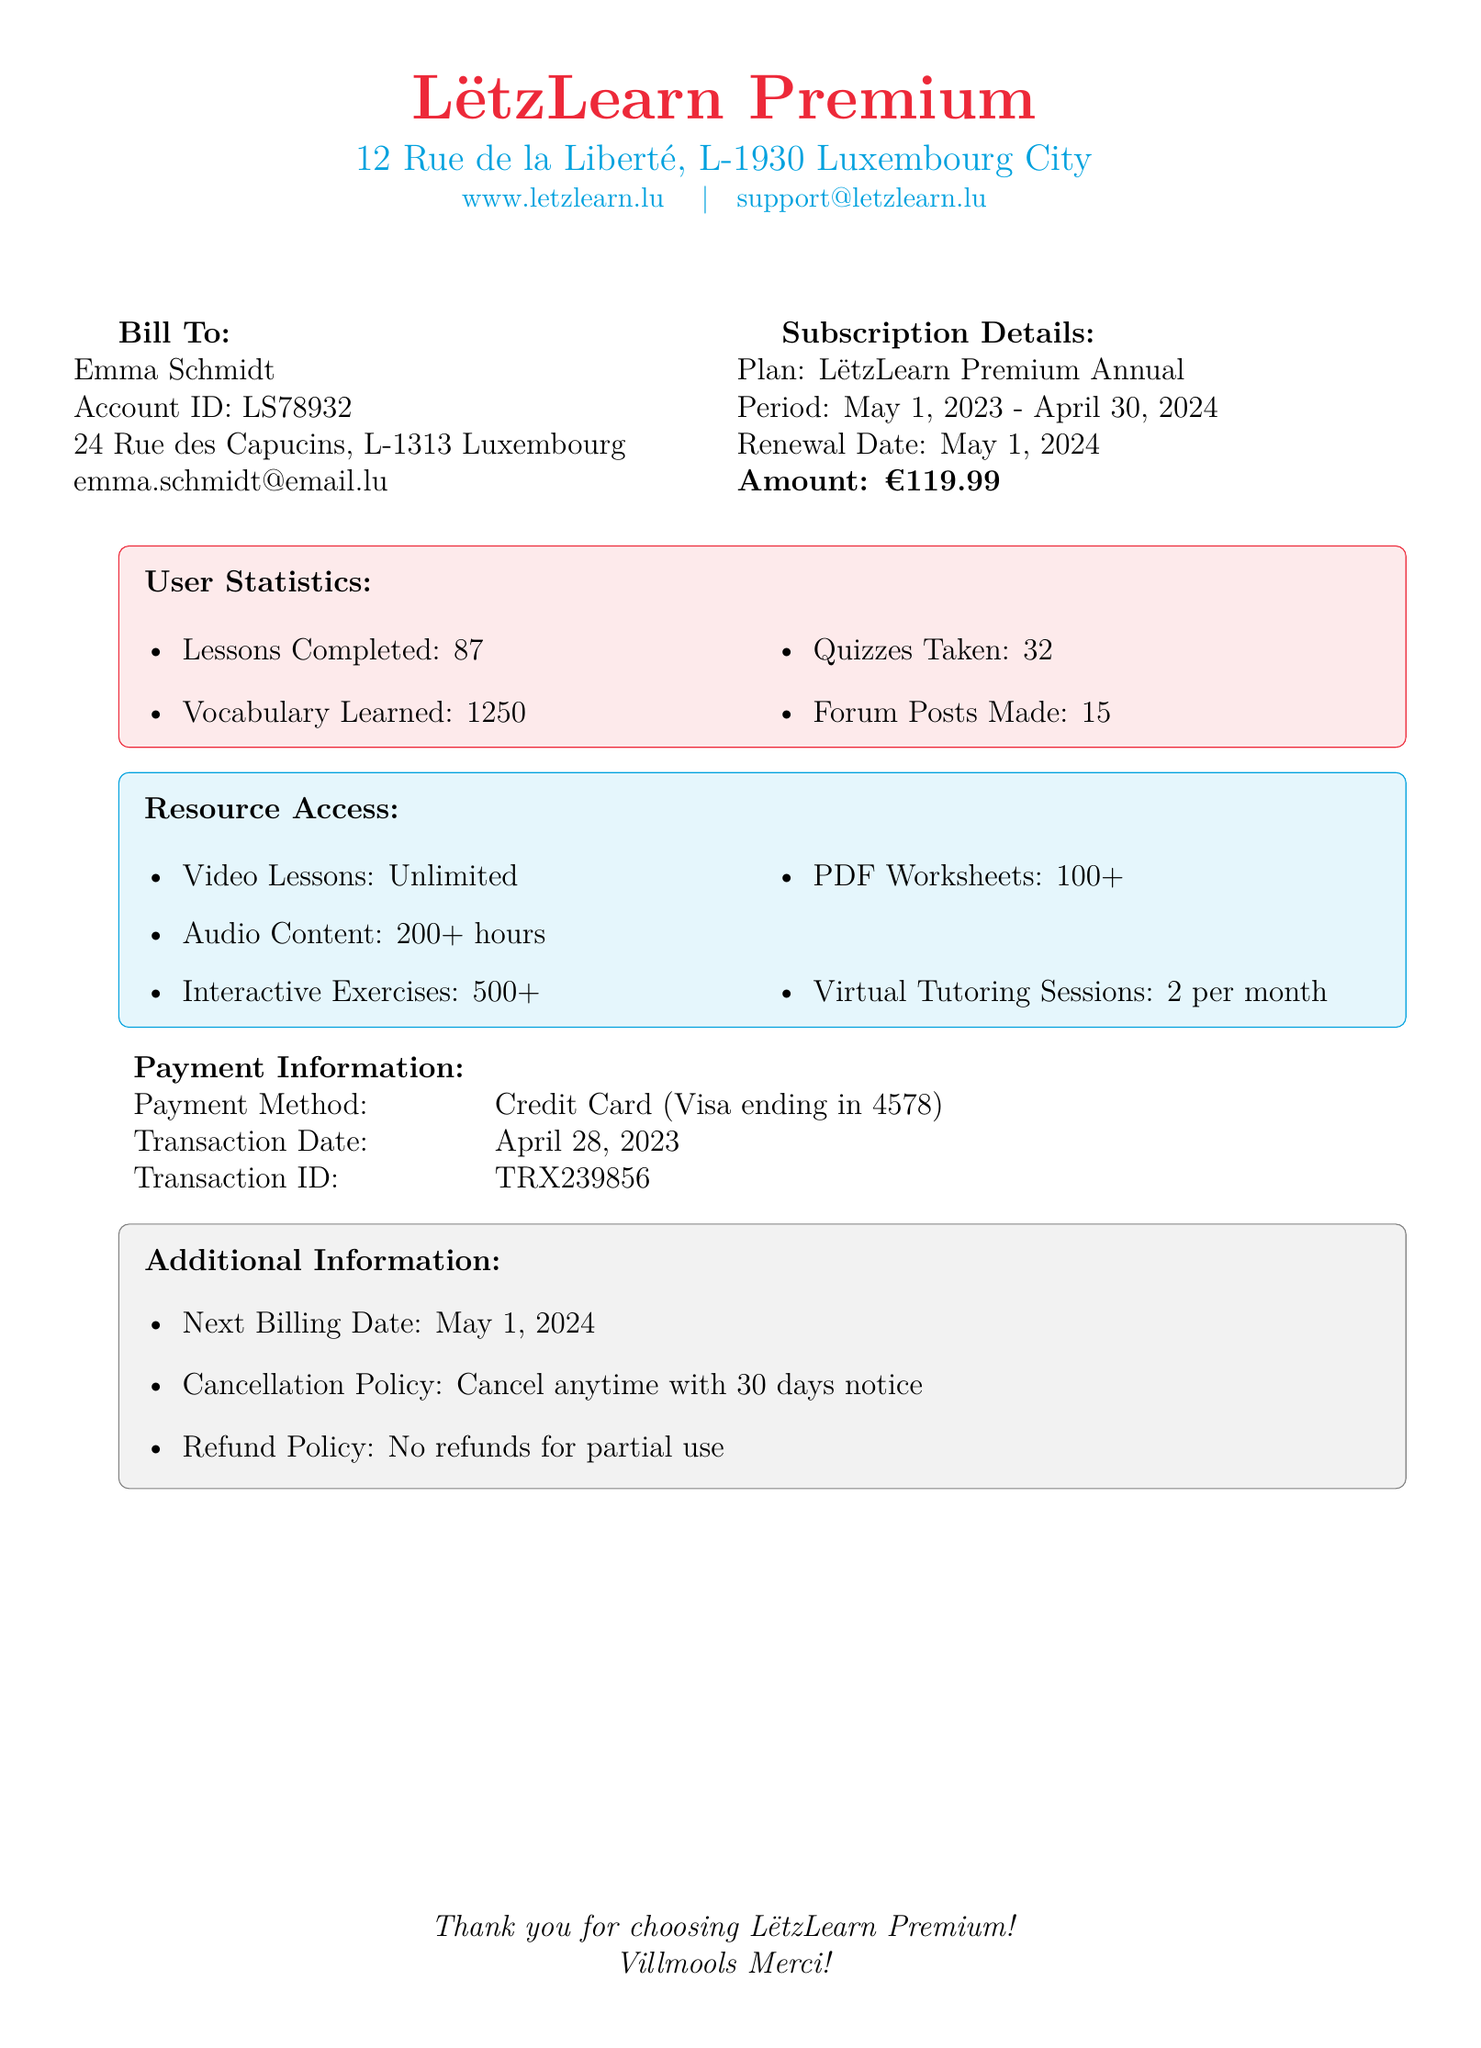What is the account ID? The account ID is listed under Bill To for Emma Schmidt.
Answer: LS78932 What is the amount due for the subscription? The amount due for the subscription is indicated in the Subscription Details section.
Answer: €119.99 How many lessons has the user completed? The number of lessons completed is found in the User Statistics section.
Answer: 87 How many virtual tutoring sessions are available per month? The number of virtual tutoring sessions is mentioned in the Resource Access section.
Answer: 2 per month What is the cancellation policy? The cancellation policy is outlined in the Additional Information section.
Answer: Cancel anytime with 30 days notice What is the transaction date? The transaction date is provided under Payment Information.
Answer: April 28, 2023 How many vocabulary words has the user learned? The vocabulary learned is reported in the User Statistics section.
Answer: 1250 What is the plan type? The plan type is clearly stated in the Subscription Details.
Answer: LëtzLearn Premium Annual What is the next billing date? The next billing date is noted in the Additional Information section.
Answer: May 1, 2024 